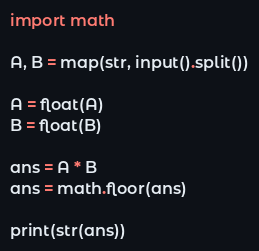Convert code to text. <code><loc_0><loc_0><loc_500><loc_500><_Python_>import math

A, B = map(str, input().split())

A = float(A)
B = float(B)

ans = A * B
ans = math.floor(ans)

print(str(ans))
</code> 